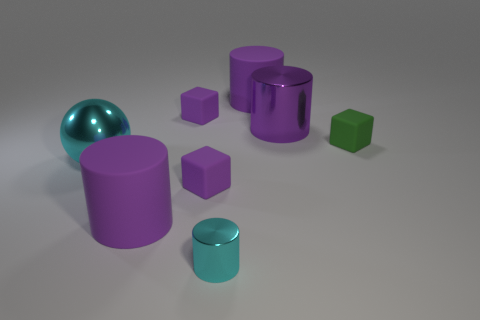Subtract all purple cylinders. How many were subtracted if there are1purple cylinders left? 2 Subtract all purple blocks. How many blocks are left? 1 Subtract all purple cylinders. How many cylinders are left? 1 Subtract 2 cubes. How many cubes are left? 1 Add 1 rubber things. How many objects exist? 9 Subtract 0 yellow spheres. How many objects are left? 8 Subtract all balls. How many objects are left? 7 Subtract all gray blocks. Subtract all red cylinders. How many blocks are left? 3 Subtract all yellow cylinders. How many purple blocks are left? 2 Subtract all big purple rubber cylinders. Subtract all large purple metallic things. How many objects are left? 5 